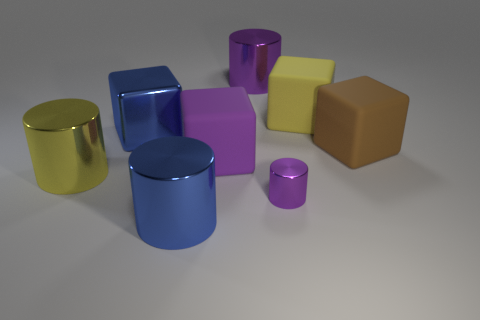Subtract all red cylinders. Subtract all red cubes. How many cylinders are left? 4 Add 1 large red metallic objects. How many objects exist? 9 Subtract 1 blue blocks. How many objects are left? 7 Subtract all purple metal things. Subtract all purple cubes. How many objects are left? 5 Add 5 cylinders. How many cylinders are left? 9 Add 2 purple metal things. How many purple metal things exist? 4 